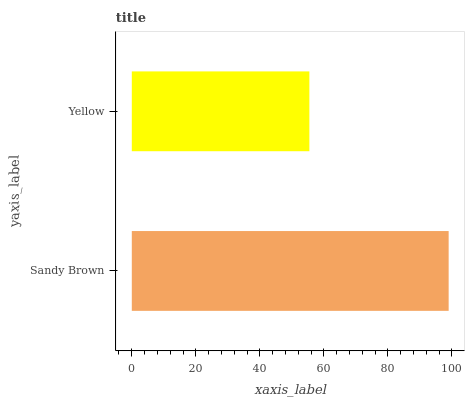Is Yellow the minimum?
Answer yes or no. Yes. Is Sandy Brown the maximum?
Answer yes or no. Yes. Is Yellow the maximum?
Answer yes or no. No. Is Sandy Brown greater than Yellow?
Answer yes or no. Yes. Is Yellow less than Sandy Brown?
Answer yes or no. Yes. Is Yellow greater than Sandy Brown?
Answer yes or no. No. Is Sandy Brown less than Yellow?
Answer yes or no. No. Is Sandy Brown the high median?
Answer yes or no. Yes. Is Yellow the low median?
Answer yes or no. Yes. Is Yellow the high median?
Answer yes or no. No. Is Sandy Brown the low median?
Answer yes or no. No. 